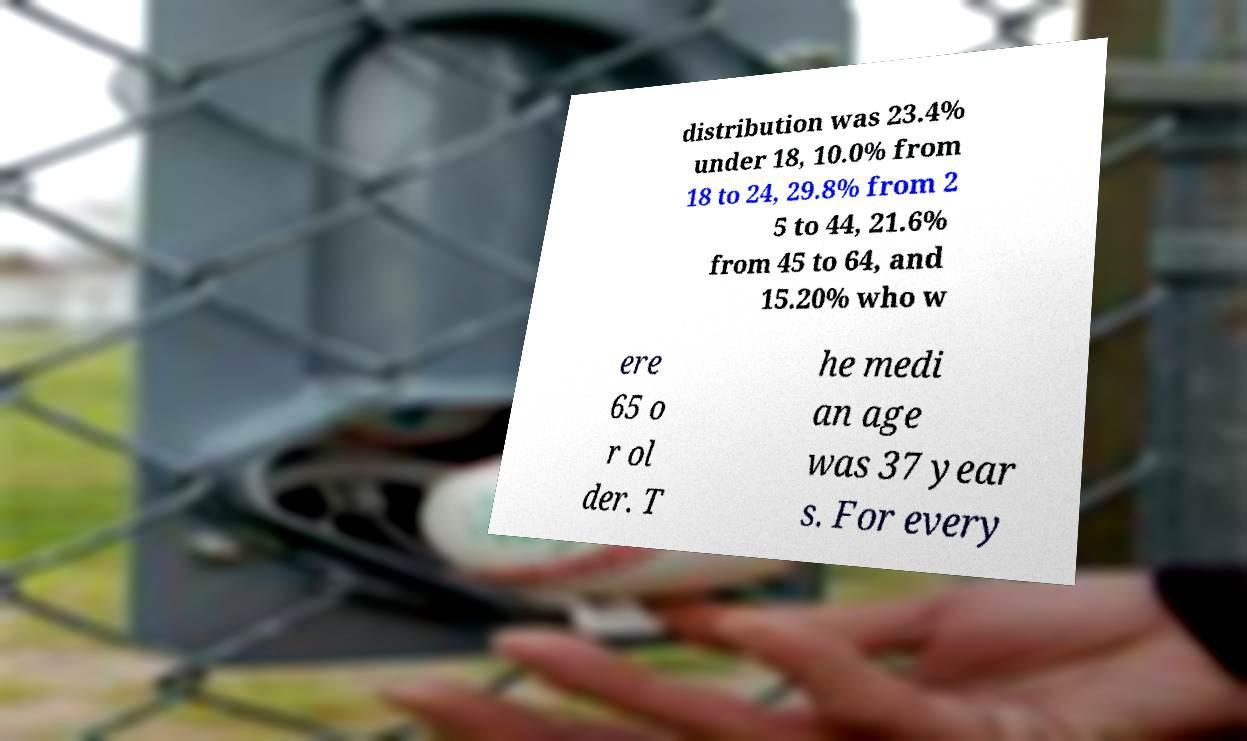What messages or text are displayed in this image? I need them in a readable, typed format. distribution was 23.4% under 18, 10.0% from 18 to 24, 29.8% from 2 5 to 44, 21.6% from 45 to 64, and 15.20% who w ere 65 o r ol der. T he medi an age was 37 year s. For every 